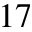Convert formula to latex. <formula><loc_0><loc_0><loc_500><loc_500>^ { 1 7 }</formula> 